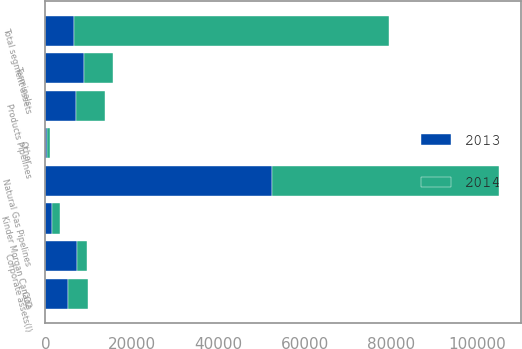Convert chart. <chart><loc_0><loc_0><loc_500><loc_500><stacked_bar_chart><ecel><fcel>Natural Gas Pipelines<fcel>CO2<fcel>Terminals<fcel>Products Pipelines<fcel>Kinder Morgan Canada<fcel>Other<fcel>Total segment assets<fcel>Corporate assets(l)<nl><fcel>2013<fcel>52523<fcel>5227<fcel>8850<fcel>7179<fcel>1593<fcel>459<fcel>6648<fcel>7311<nl><fcel>2014<fcel>52357<fcel>4708<fcel>6888<fcel>6648<fcel>1677<fcel>568<fcel>72846<fcel>2339<nl></chart> 